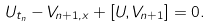<formula> <loc_0><loc_0><loc_500><loc_500>U _ { t _ { n } } - V _ { n + 1 , x } + [ U , V _ { n + 1 } ] = 0 .</formula> 